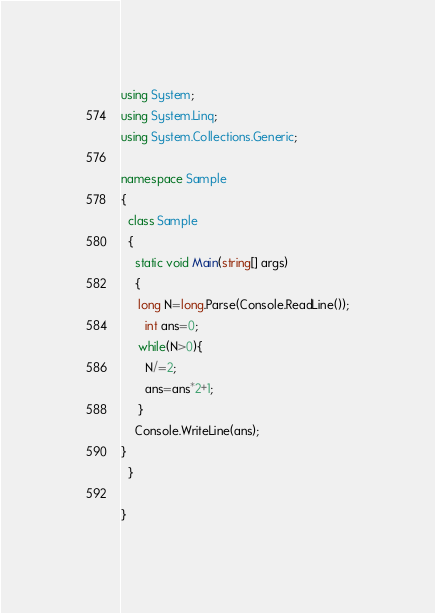Convert code to text. <code><loc_0><loc_0><loc_500><loc_500><_C#_>using System;
using System.Linq;
using System.Collections.Generic;

namespace Sample
{
  class Sample
  {
    static void Main(string[] args)
    {
     long N=long.Parse(Console.ReadLine());
       int ans=0;
     while(N>0){
       N/=2;
       ans=ans*2+1;
     }
	Console.WriteLine(ans);
}
  }

}
</code> 